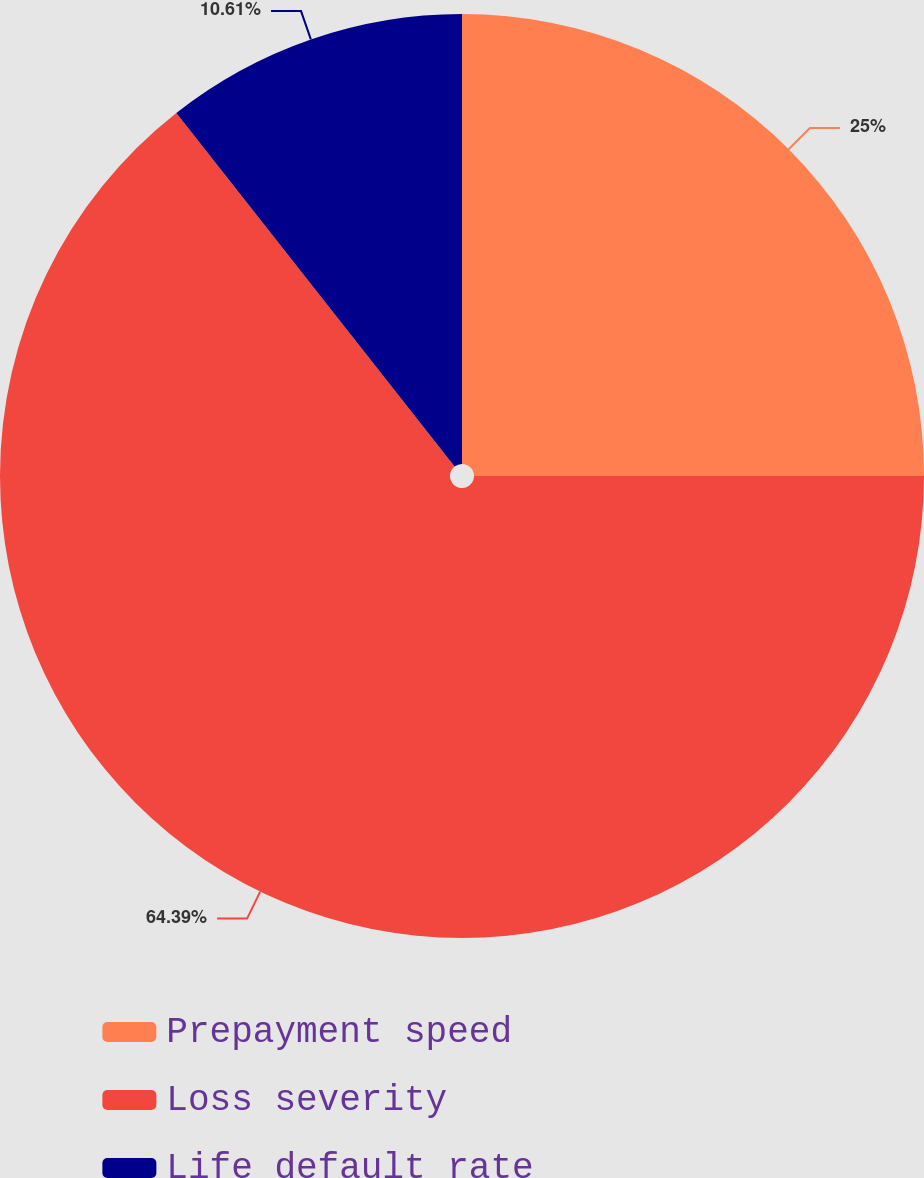Convert chart. <chart><loc_0><loc_0><loc_500><loc_500><pie_chart><fcel>Prepayment speed<fcel>Loss severity<fcel>Life default rate<nl><fcel>25.0%<fcel>64.39%<fcel>10.61%<nl></chart> 